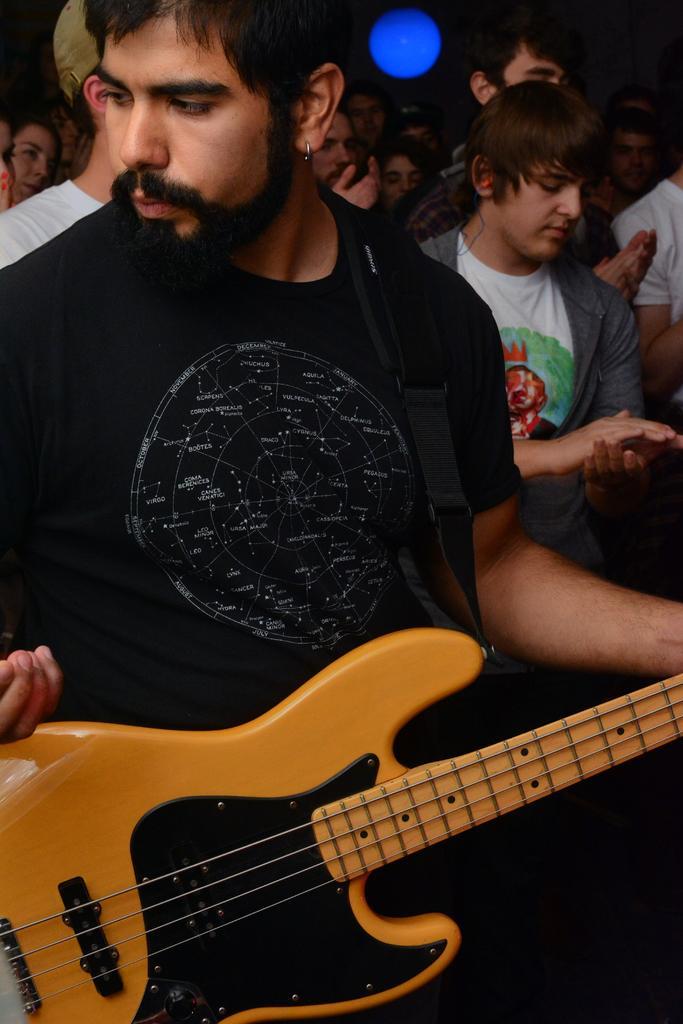Can you describe this image briefly? Bottom left side of the image a man is standing and holding a guitar. Behind him few people are standing. Top of the image there is a blue color light. 